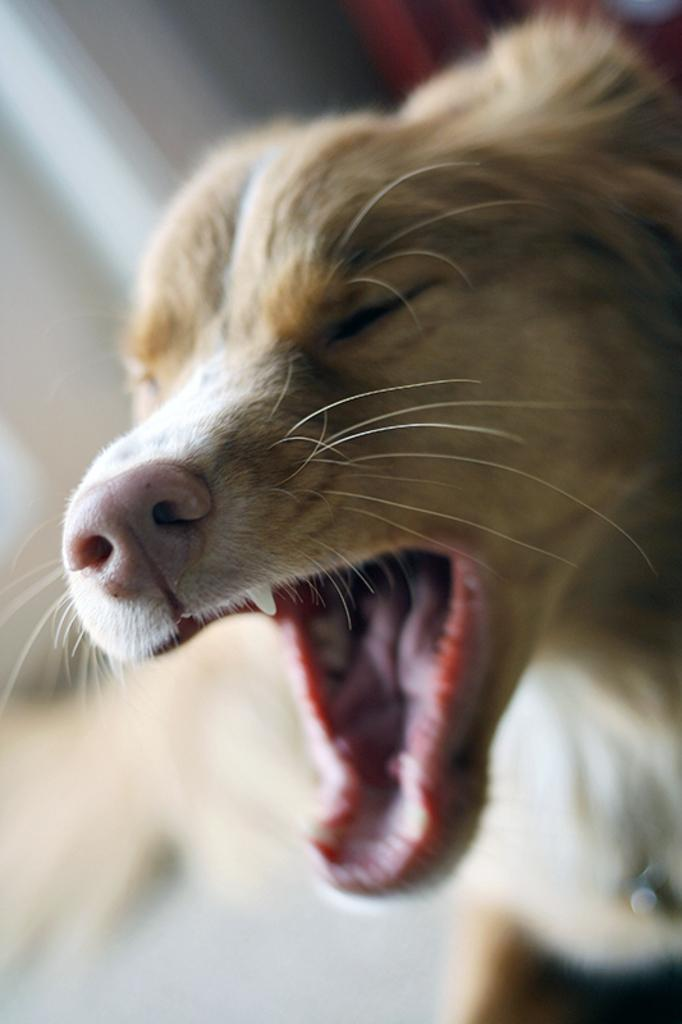What animal is present in the image? There is a dog in the picture. What is the dog doing in the image? The dog is opening its mouth. Can you describe the dog's possible action based on its open mouth? The dog might be barking. What can be seen in the background of the image? There is a white wall in the background of the picture. How is the wall depicted in the image? The wall is blurred in the background. What type of division is taking place between the dog and the wall in the image? There is no division present in the image; it is a dog and a blurred white wall in the background. What role does the spoon play in the interaction between the dog and the wall? There is no spoon present in the image, so it cannot play any role in the interaction between the dog and the wall. 